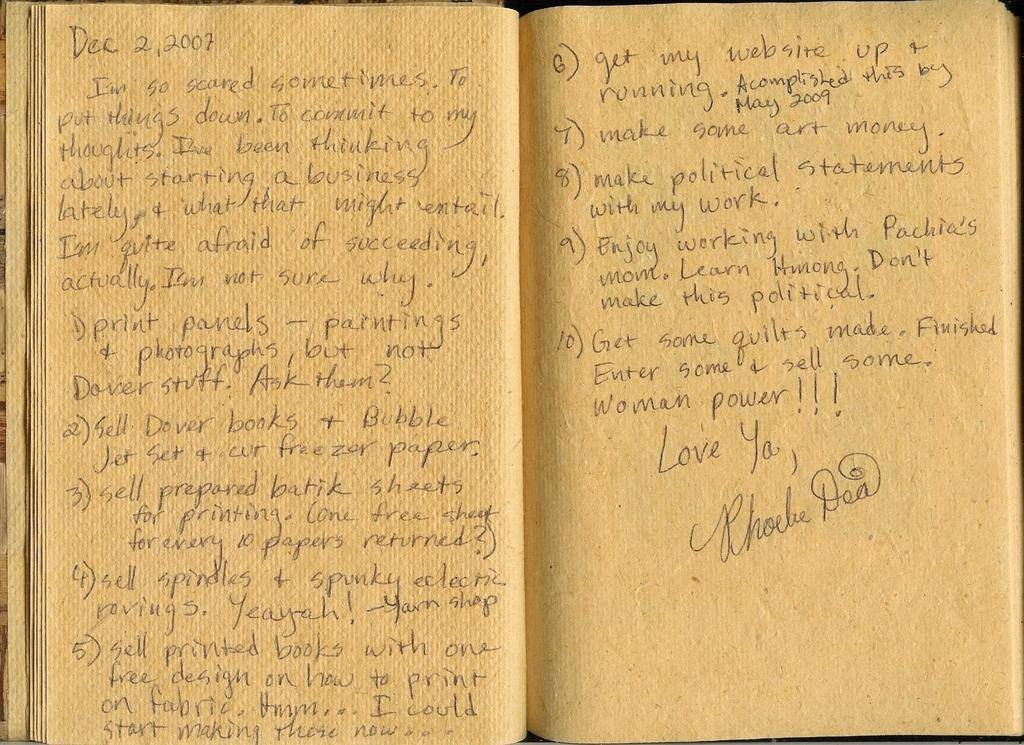<image>
Offer a succinct explanation of the picture presented. Phoebe Dea wrote 10 goals on the yellow pages of a book. 